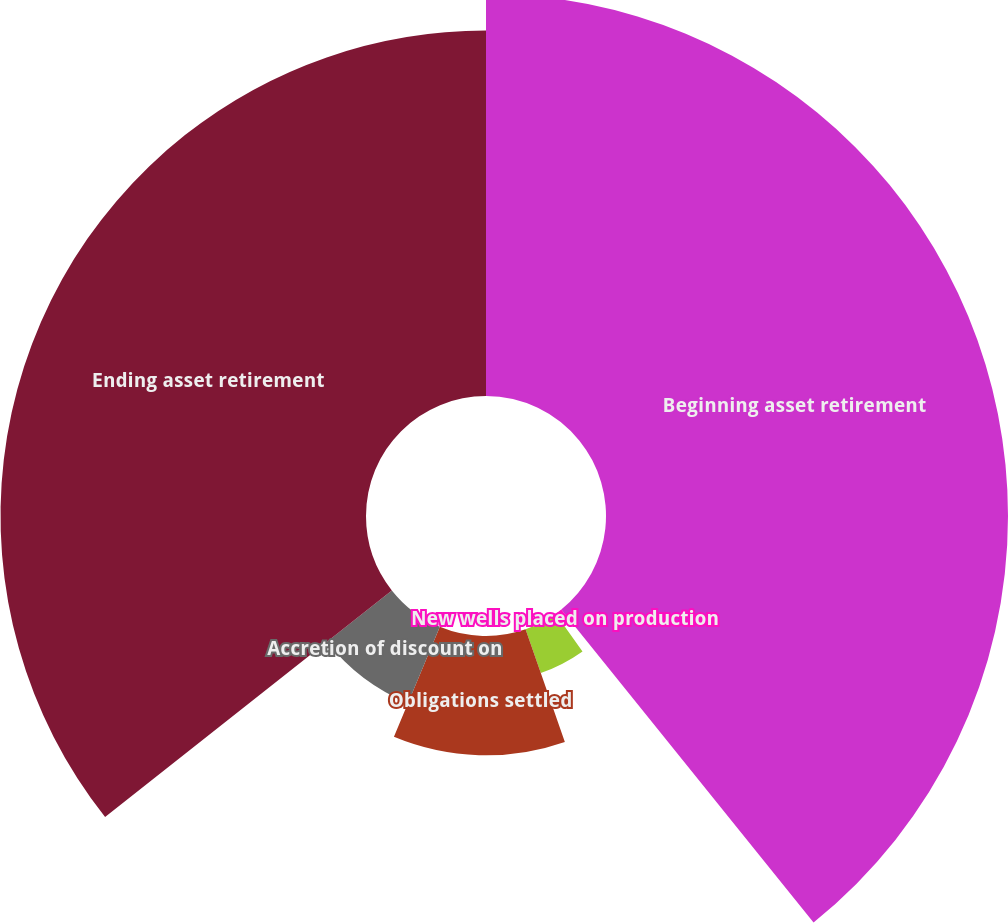<chart> <loc_0><loc_0><loc_500><loc_500><pie_chart><fcel>Beginning asset retirement<fcel>New wells placed on production<fcel>Changes in estimates (a)<fcel>Obligations settled<fcel>Accretion of discount on<fcel>Ending asset retirement<nl><fcel>39.2%<fcel>0.94%<fcel>4.51%<fcel>11.63%<fcel>8.07%<fcel>35.64%<nl></chart> 